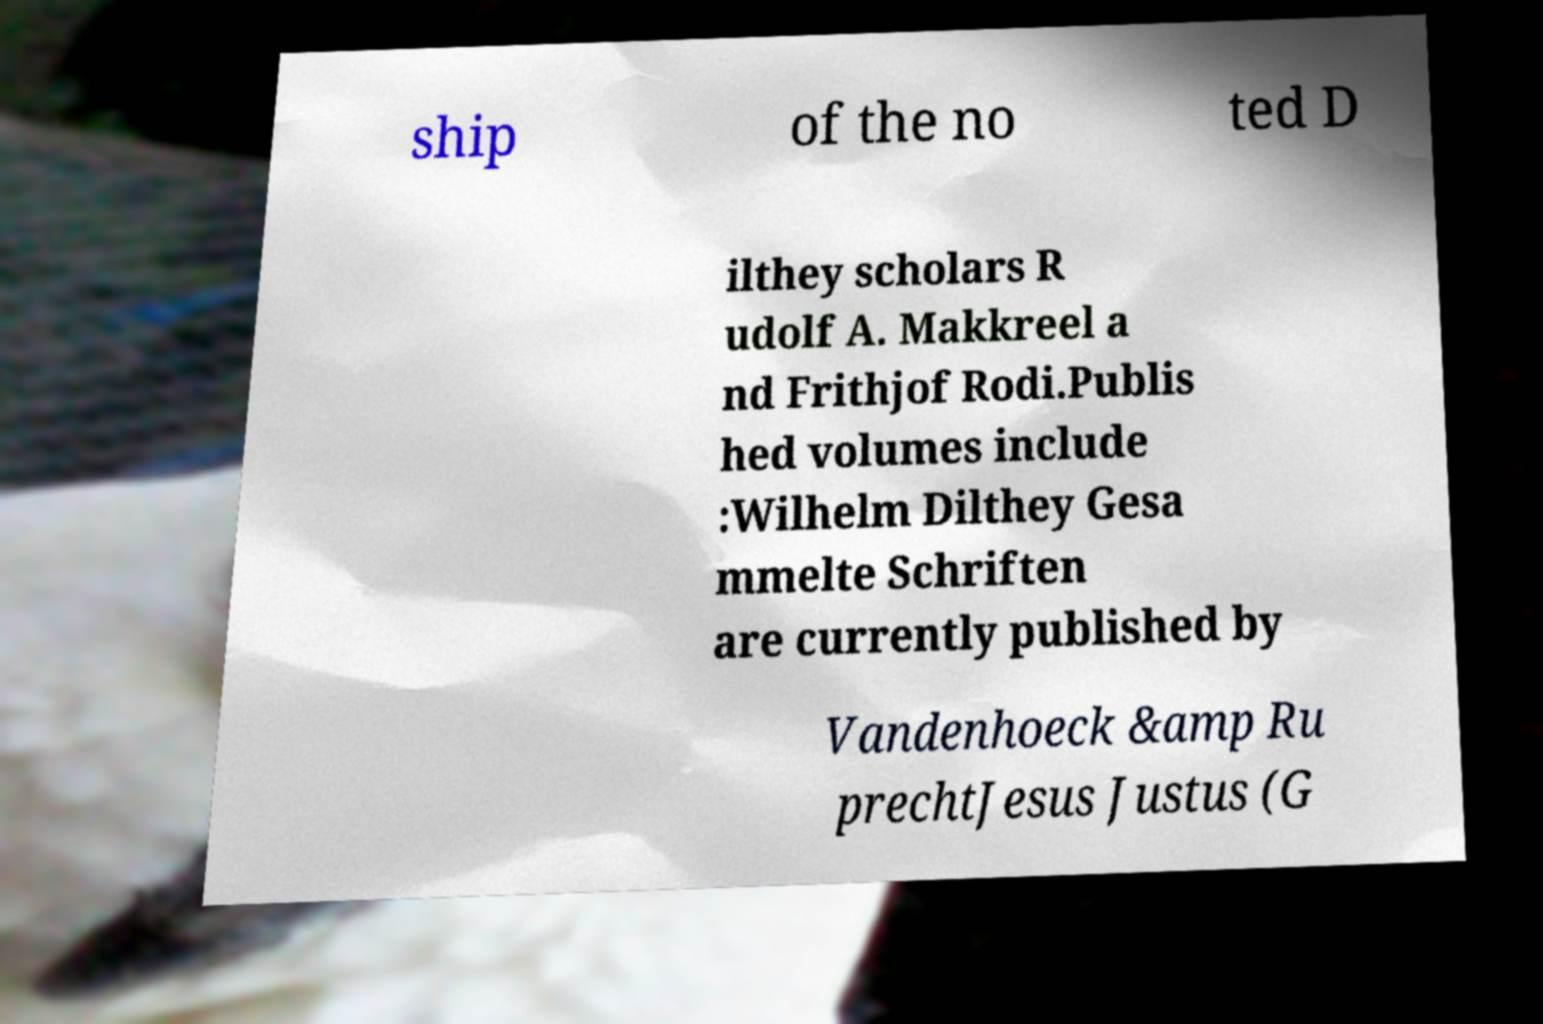Please identify and transcribe the text found in this image. ship of the no ted D ilthey scholars R udolf A. Makkreel a nd Frithjof Rodi.Publis hed volumes include :Wilhelm Dilthey Gesa mmelte Schriften are currently published by Vandenhoeck &amp Ru prechtJesus Justus (G 